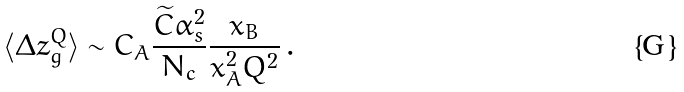Convert formula to latex. <formula><loc_0><loc_0><loc_500><loc_500>\langle \Delta z _ { g } ^ { Q } \rangle \sim C _ { A } \frac { \widetilde { C } \alpha _ { s } ^ { 2 } } { N _ { c } } \frac { x _ { B } } { x _ { A } ^ { 2 } Q ^ { 2 } } \, .</formula> 